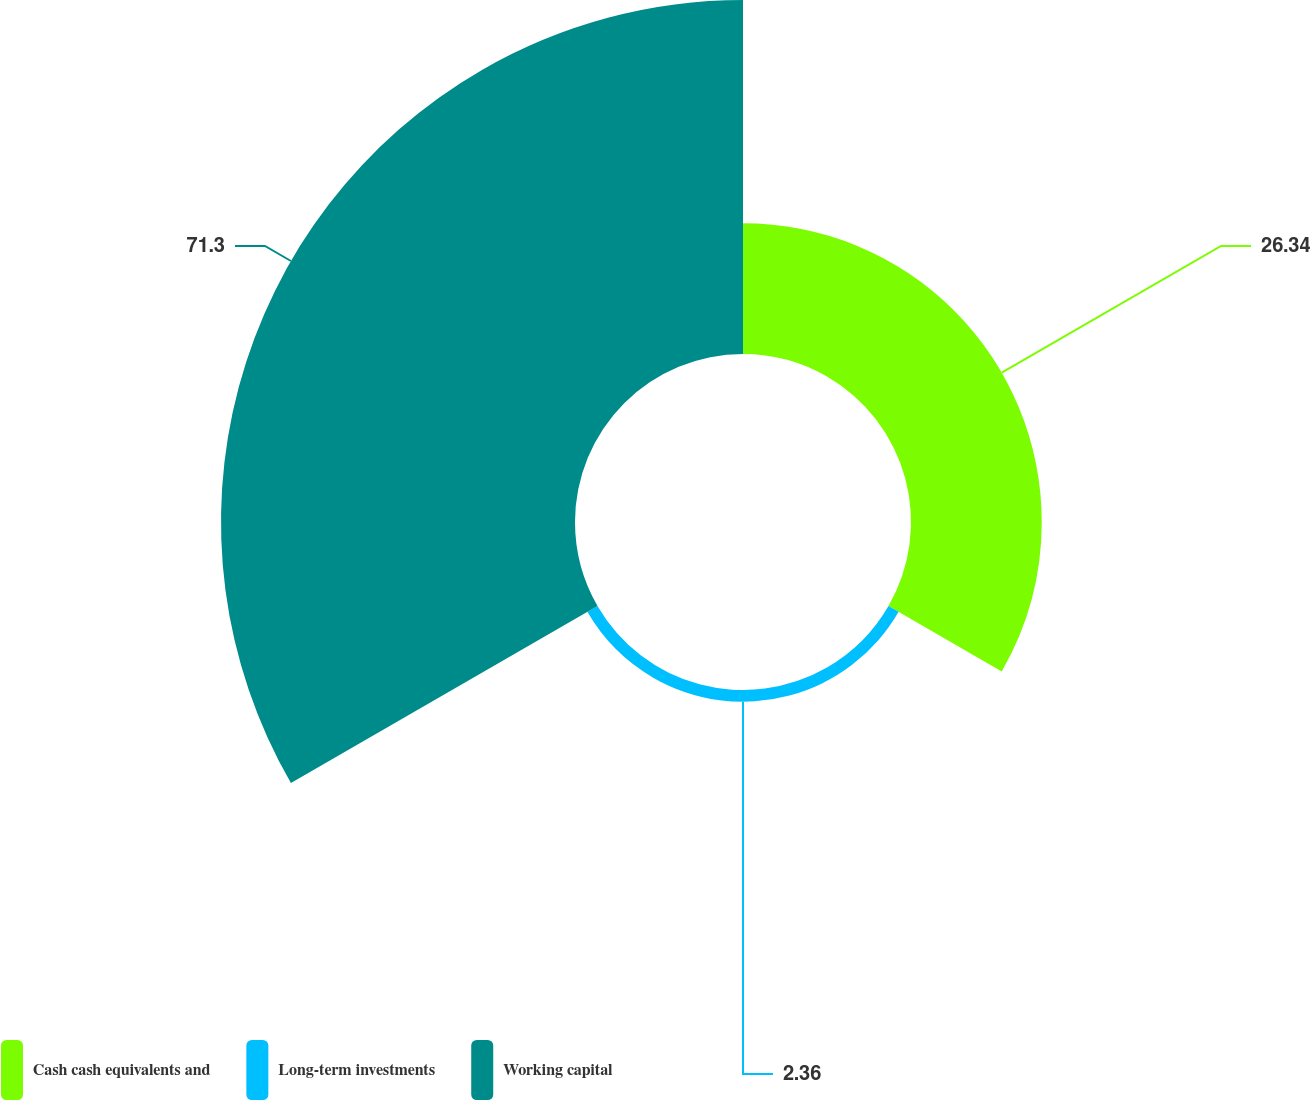Convert chart. <chart><loc_0><loc_0><loc_500><loc_500><pie_chart><fcel>Cash cash equivalents and<fcel>Long-term investments<fcel>Working capital<nl><fcel>26.34%<fcel>2.36%<fcel>71.31%<nl></chart> 